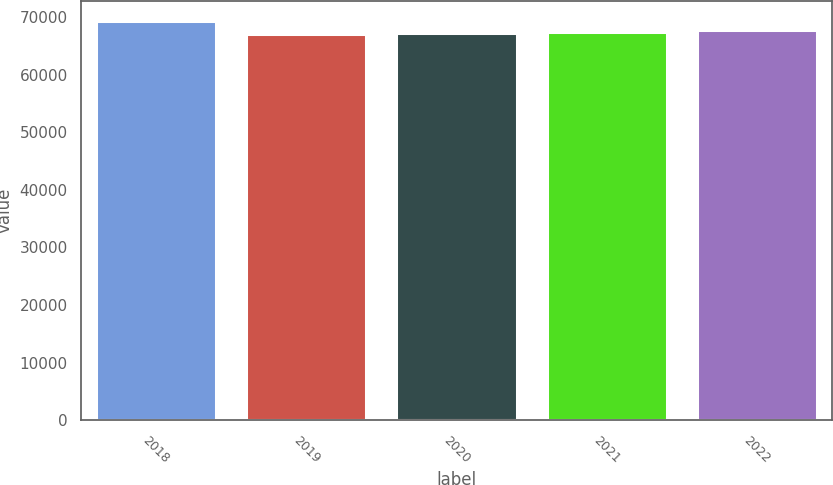Convert chart. <chart><loc_0><loc_0><loc_500><loc_500><bar_chart><fcel>2018<fcel>2019<fcel>2020<fcel>2021<fcel>2022<nl><fcel>69344<fcel>67011<fcel>67244.3<fcel>67477.6<fcel>67710.9<nl></chart> 